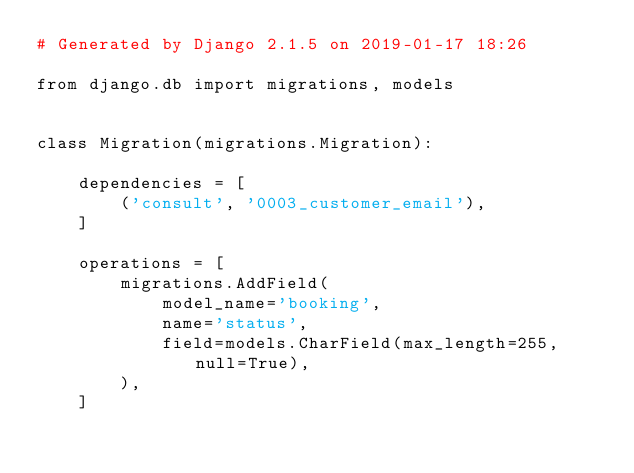<code> <loc_0><loc_0><loc_500><loc_500><_Python_># Generated by Django 2.1.5 on 2019-01-17 18:26

from django.db import migrations, models


class Migration(migrations.Migration):

    dependencies = [
        ('consult', '0003_customer_email'),
    ]

    operations = [
        migrations.AddField(
            model_name='booking',
            name='status',
            field=models.CharField(max_length=255, null=True),
        ),
    ]
</code> 